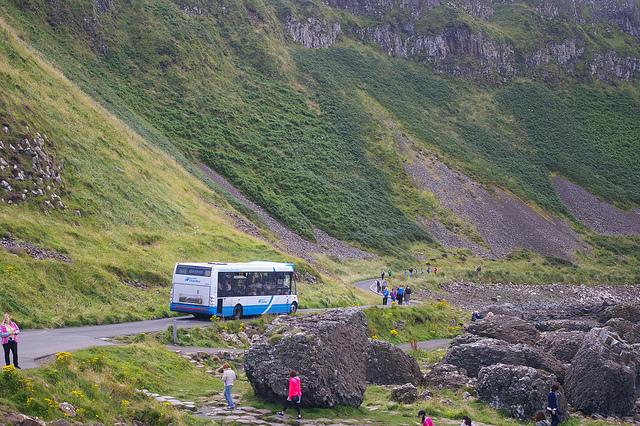Which way will the driver have to turn the wheel to follow the first curve?
Short answer required. Left. Are there any passenger's in the bus?
Quick response, please. Yes. What kind of transportation is pictured?
Quick response, please. Bus. How many people are in this photo?
Concise answer only. 20. What is traveling on the road?
Short answer required. Bus. 